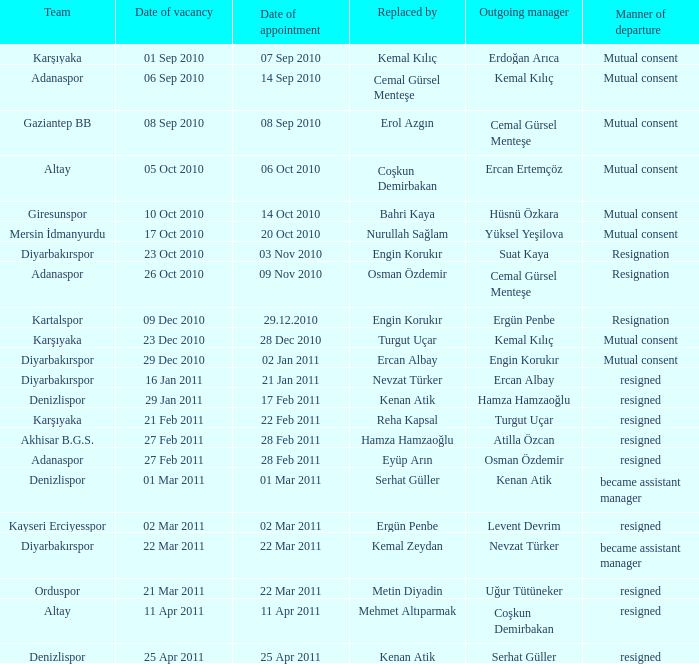Who replaced the outgoing manager Hüsnü Özkara?  Bahri Kaya. 